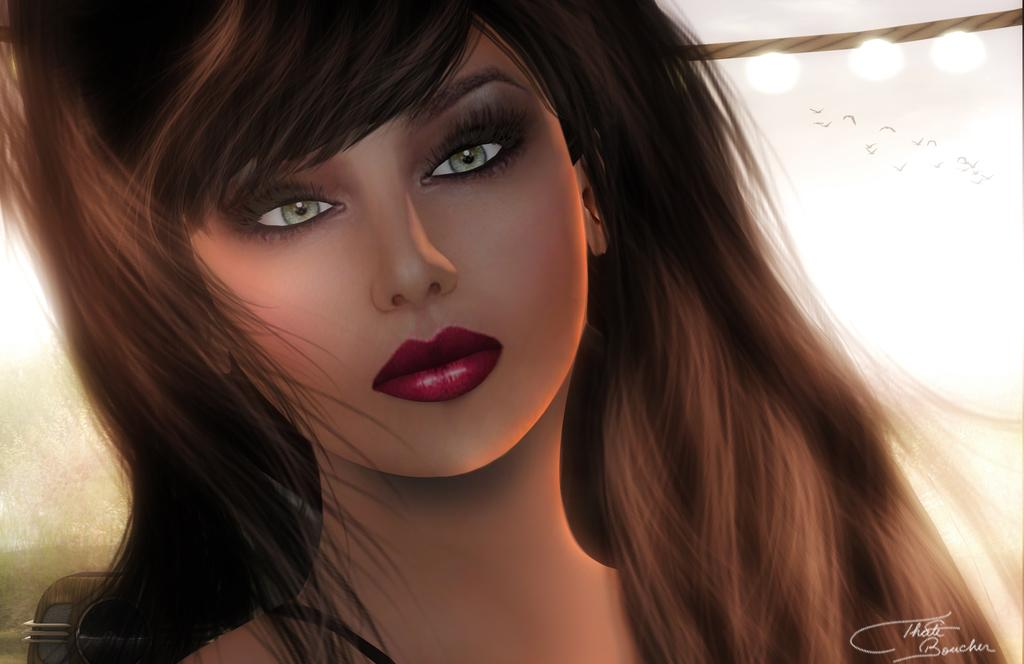What type of character is present in the image? There is an animated person in the image. What can be seen in the image besides the animated person? There are lights and birds visible in the image. What is written at the bottom of the image? There is text at the bottom of the image. What advice does the animated person's uncle give in the image? There is no uncle present in the image, so it is not possible to determine any advice given. 